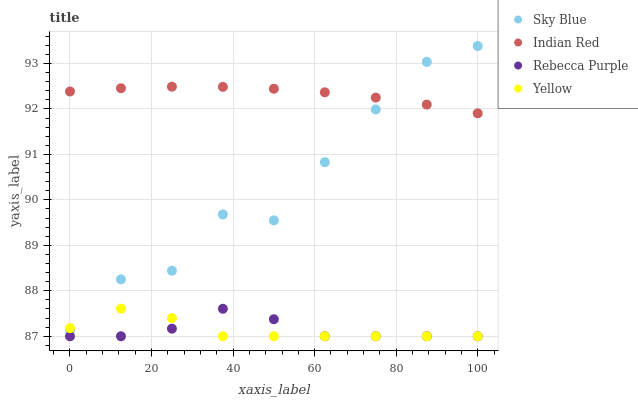Does Yellow have the minimum area under the curve?
Answer yes or no. Yes. Does Indian Red have the maximum area under the curve?
Answer yes or no. Yes. Does Rebecca Purple have the minimum area under the curve?
Answer yes or no. No. Does Rebecca Purple have the maximum area under the curve?
Answer yes or no. No. Is Indian Red the smoothest?
Answer yes or no. Yes. Is Sky Blue the roughest?
Answer yes or no. Yes. Is Yellow the smoothest?
Answer yes or no. No. Is Yellow the roughest?
Answer yes or no. No. Does Yellow have the lowest value?
Answer yes or no. Yes. Does Indian Red have the lowest value?
Answer yes or no. No. Does Sky Blue have the highest value?
Answer yes or no. Yes. Does Yellow have the highest value?
Answer yes or no. No. Is Rebecca Purple less than Indian Red?
Answer yes or no. Yes. Is Indian Red greater than Rebecca Purple?
Answer yes or no. Yes. Does Sky Blue intersect Indian Red?
Answer yes or no. Yes. Is Sky Blue less than Indian Red?
Answer yes or no. No. Is Sky Blue greater than Indian Red?
Answer yes or no. No. Does Rebecca Purple intersect Indian Red?
Answer yes or no. No. 